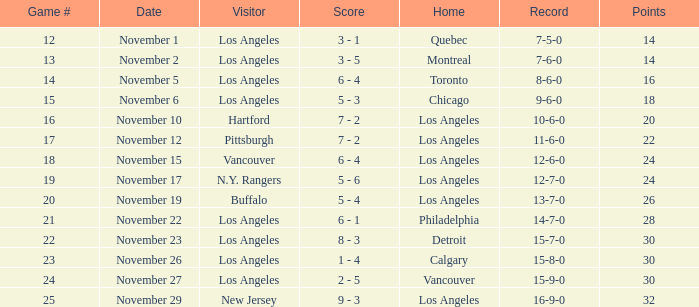Who is the visitor team of game 19 with Los Angeles as the home team? N.Y. Rangers. 